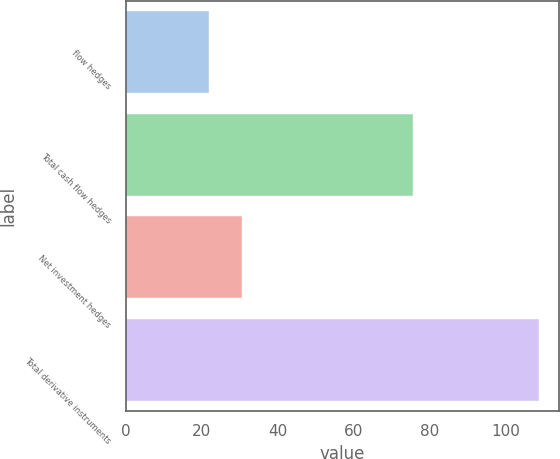<chart> <loc_0><loc_0><loc_500><loc_500><bar_chart><fcel>flow hedges<fcel>Total cash flow hedges<fcel>Net investment hedges<fcel>Total derivative instruments<nl><fcel>21.8<fcel>75.6<fcel>30.48<fcel>108.6<nl></chart> 